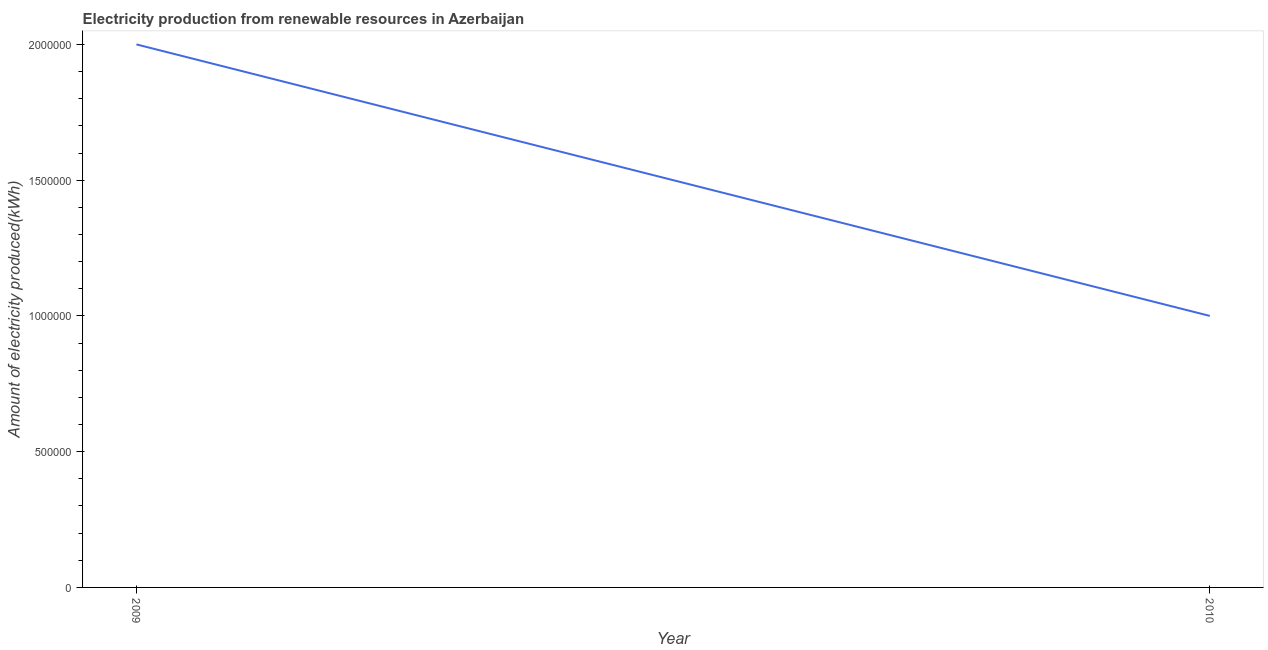What is the amount of electricity produced in 2010?
Your response must be concise. 1.00e+06. Across all years, what is the maximum amount of electricity produced?
Keep it short and to the point. 2.00e+06. Across all years, what is the minimum amount of electricity produced?
Offer a very short reply. 1.00e+06. In which year was the amount of electricity produced maximum?
Keep it short and to the point. 2009. What is the sum of the amount of electricity produced?
Your answer should be compact. 3.00e+06. What is the difference between the amount of electricity produced in 2009 and 2010?
Provide a short and direct response. 1.00e+06. What is the average amount of electricity produced per year?
Your answer should be very brief. 1.50e+06. What is the median amount of electricity produced?
Keep it short and to the point. 1.50e+06. What is the ratio of the amount of electricity produced in 2009 to that in 2010?
Keep it short and to the point. 2. In how many years, is the amount of electricity produced greater than the average amount of electricity produced taken over all years?
Your response must be concise. 1. Does the amount of electricity produced monotonically increase over the years?
Offer a terse response. No. How many lines are there?
Ensure brevity in your answer.  1. How many years are there in the graph?
Ensure brevity in your answer.  2. What is the difference between two consecutive major ticks on the Y-axis?
Provide a short and direct response. 5.00e+05. Are the values on the major ticks of Y-axis written in scientific E-notation?
Ensure brevity in your answer.  No. What is the title of the graph?
Offer a very short reply. Electricity production from renewable resources in Azerbaijan. What is the label or title of the X-axis?
Provide a succinct answer. Year. What is the label or title of the Y-axis?
Give a very brief answer. Amount of electricity produced(kWh). What is the Amount of electricity produced(kWh) of 2009?
Keep it short and to the point. 2.00e+06. What is the ratio of the Amount of electricity produced(kWh) in 2009 to that in 2010?
Keep it short and to the point. 2. 